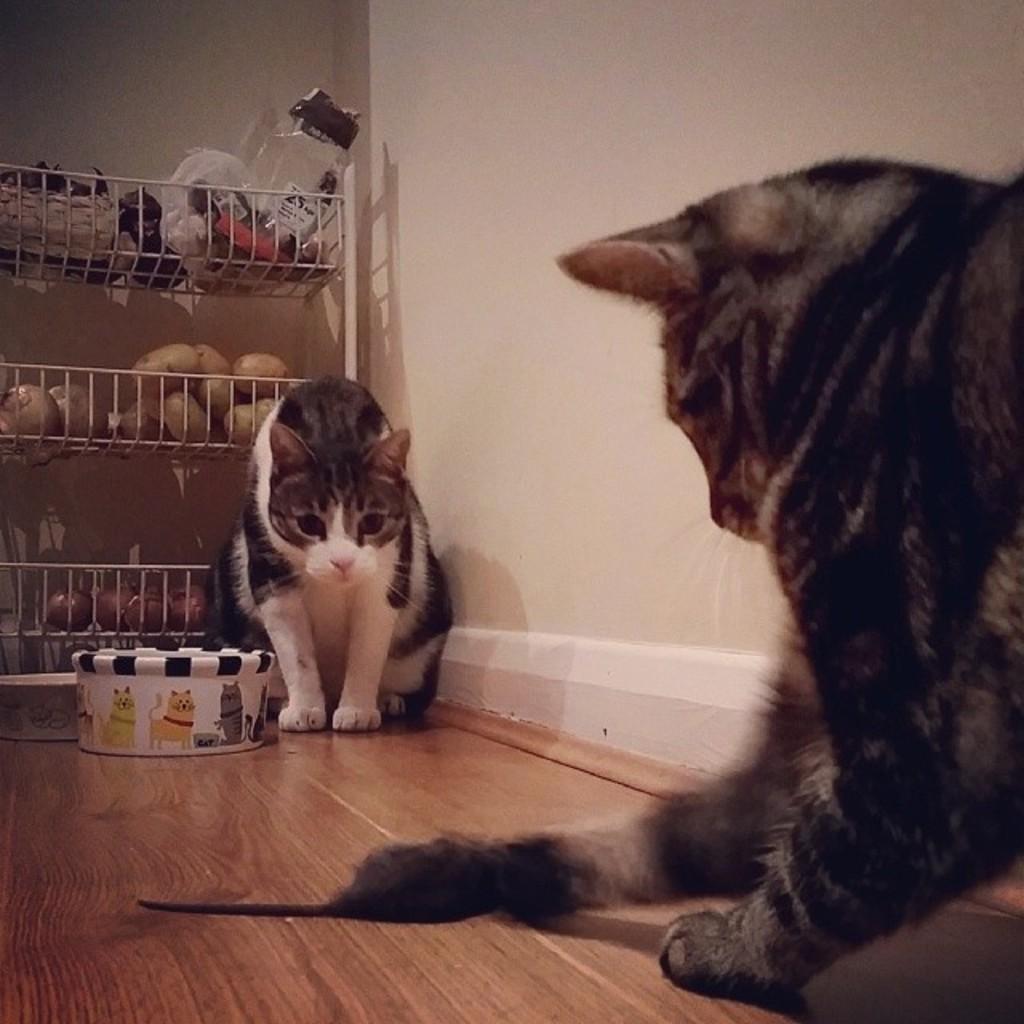Could you give a brief overview of what you see in this image? This is an inside view of a room. Here I can see two cats are sitting on the floor. Beside the cat I can see a white color box. On the left side there is a rack in which few potatoes, onions and some other objects are placed. In the background, I can see the wall. 